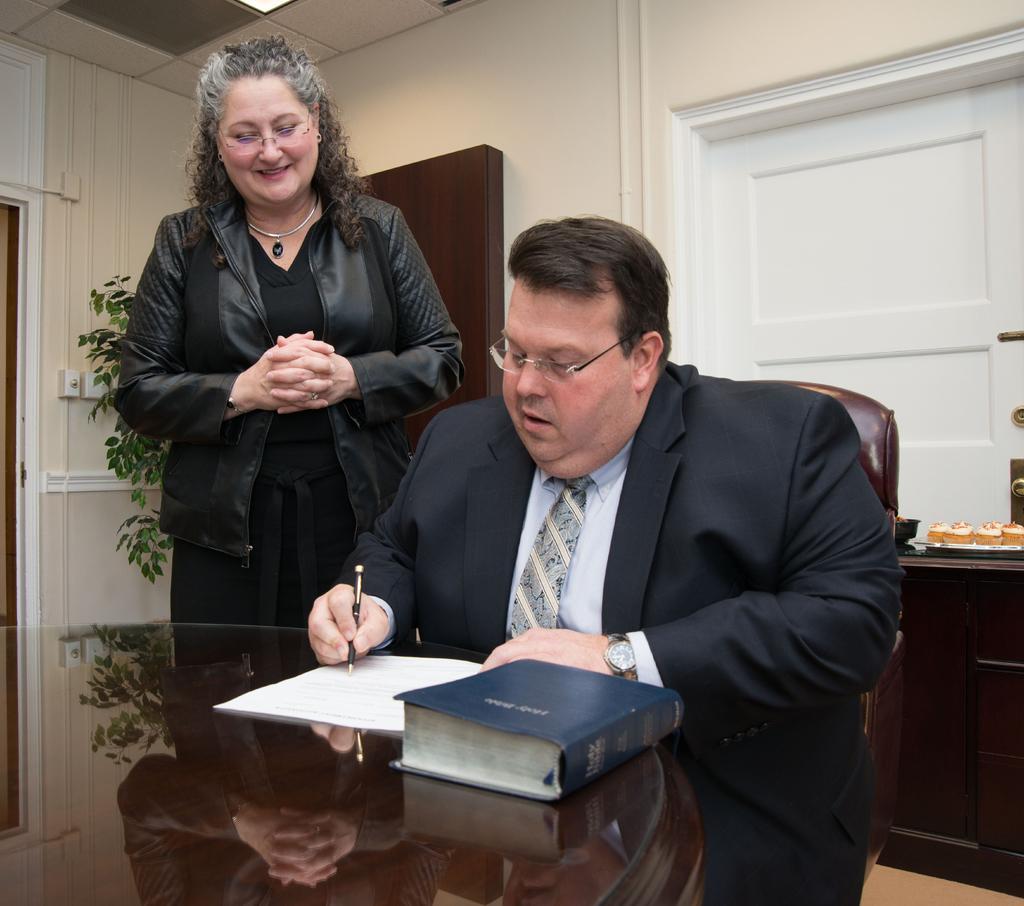Could you give a brief overview of what you see in this image? The image is inside the room. In the image there are two persons man and woman. Man is sitting on chair holding his pen and writing something on his paper which is placed on table. On table we can see a book, in background we can see a white door which is closed. On left side there are some plants which are in green color,switch board and a wall which is in cream color. 